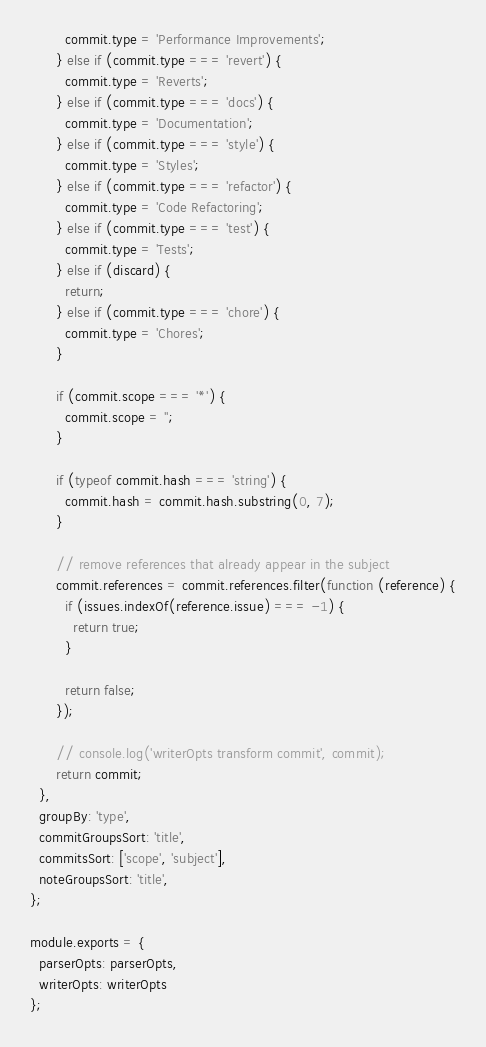Convert code to text. <code><loc_0><loc_0><loc_500><loc_500><_JavaScript_>        commit.type = 'Performance Improvements';
      } else if (commit.type === 'revert') {
        commit.type = 'Reverts';
      } else if (commit.type === 'docs') {
        commit.type = 'Documentation';
      } else if (commit.type === 'style') {
        commit.type = 'Styles';
      } else if (commit.type === 'refactor') {
        commit.type = 'Code Refactoring';
      } else if (commit.type === 'test') {
        commit.type = 'Tests';
      } else if (discard) {
        return;
      } else if (commit.type === 'chore') {
        commit.type = 'Chores';
      }

      if (commit.scope === '*') {
        commit.scope = '';
      }

      if (typeof commit.hash === 'string') {
        commit.hash = commit.hash.substring(0, 7);
      }

      // remove references that already appear in the subject
      commit.references = commit.references.filter(function (reference) {
        if (issues.indexOf(reference.issue) === -1) {
          return true;
        }

        return false;
      });

      // console.log('writerOpts transform commit', commit);
      return commit;
  },
  groupBy: 'type',
  commitGroupsSort: 'title',
  commitsSort: ['scope', 'subject'],
  noteGroupsSort: 'title',
};

module.exports = {
  parserOpts: parserOpts,
  writerOpts: writerOpts
};
</code> 